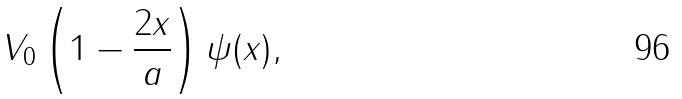Convert formula to latex. <formula><loc_0><loc_0><loc_500><loc_500>V _ { 0 } \left ( 1 - \frac { 2 x } { a } \right ) \psi ( x ) ,</formula> 